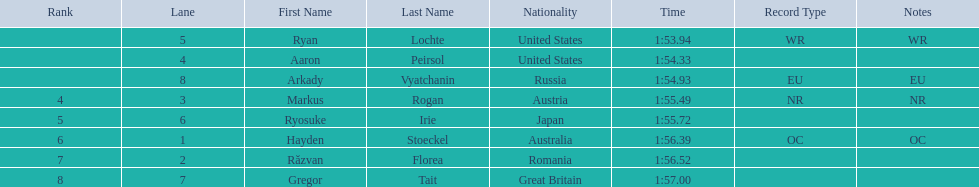Who participated in the event? Ryan Lochte, Aaron Peirsol, Arkady Vyatchanin, Markus Rogan, Ryosuke Irie, Hayden Stoeckel, Răzvan Florea, Gregor Tait. What was the finishing time of each athlete? 1:53.94, 1:54.33, 1:54.93, 1:55.49, 1:55.72, 1:56.39, 1:56.52, 1:57.00. How about just ryosuke irie? 1:55.72. 